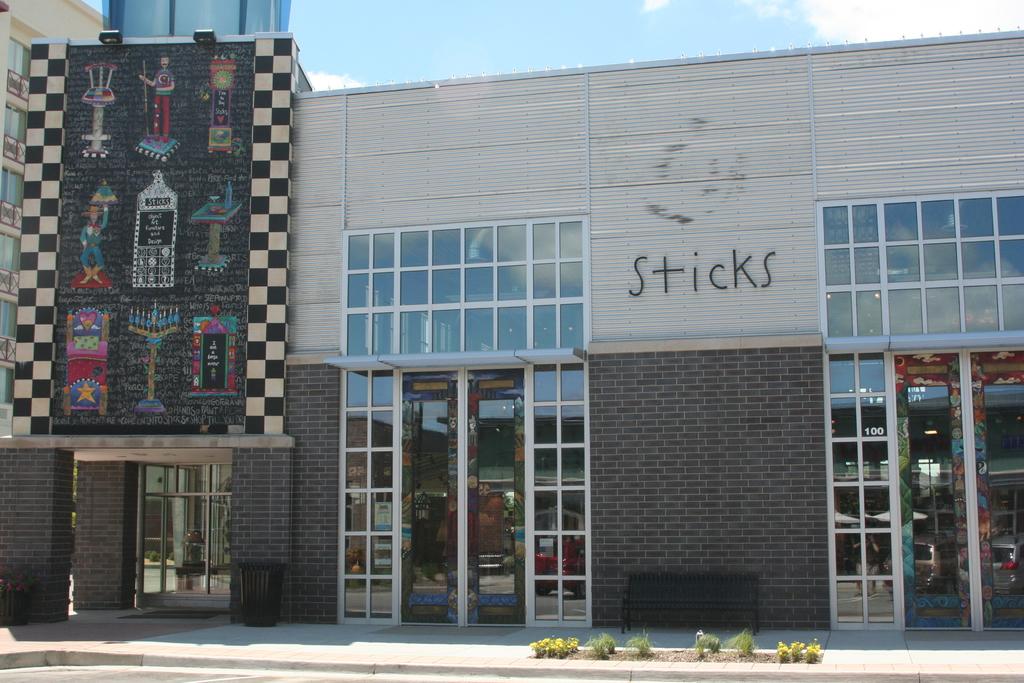What do the black letters say?
Provide a short and direct response. Sticks. What is the numerical address of this store?
Make the answer very short. 100. 